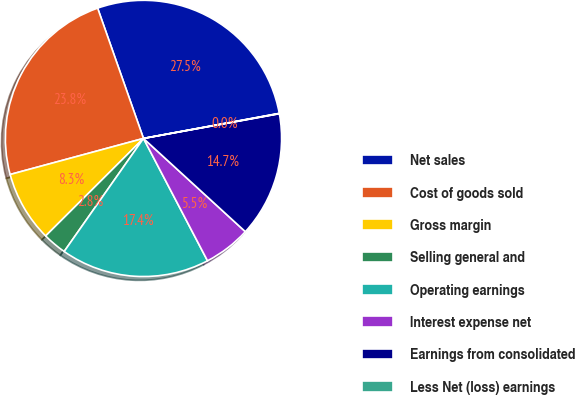Convert chart. <chart><loc_0><loc_0><loc_500><loc_500><pie_chart><fcel>Net sales<fcel>Cost of goods sold<fcel>Gross margin<fcel>Selling general and<fcel>Operating earnings<fcel>Interest expense net<fcel>Earnings from consolidated<fcel>Less Net (loss) earnings<nl><fcel>27.48%<fcel>23.82%<fcel>8.27%<fcel>2.79%<fcel>17.41%<fcel>5.53%<fcel>14.66%<fcel>0.04%<nl></chart> 